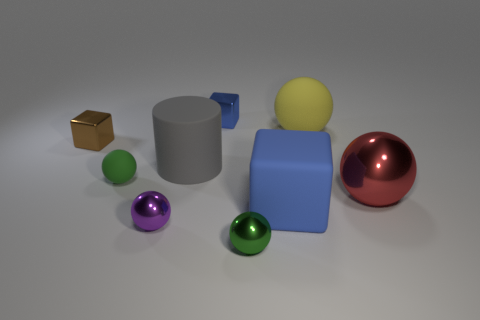Which objects in the image are reflective? Several objects in the image have reflective surfaces, including the red ball, the green and purple smaller balls, and the gold cube. 